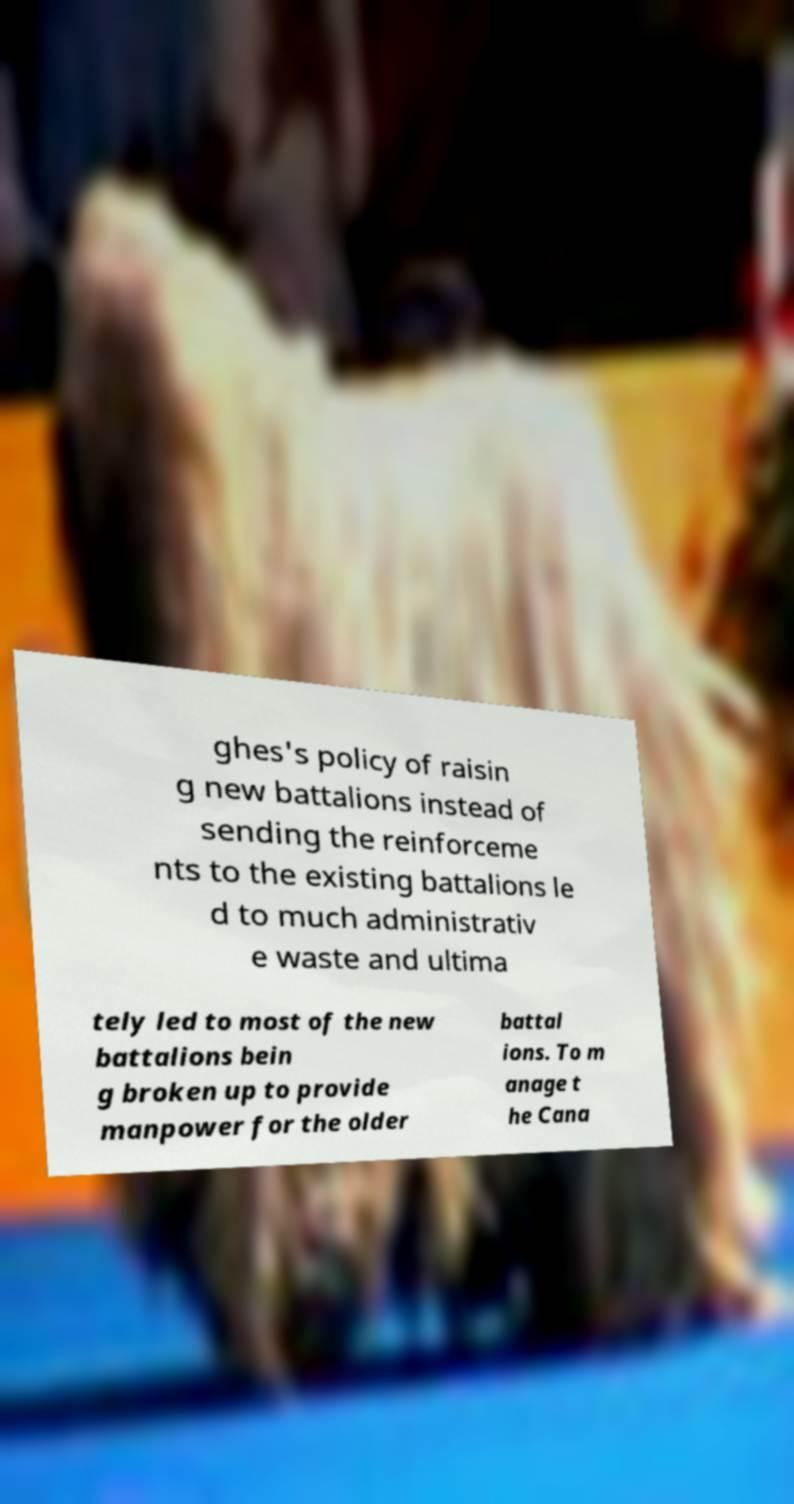Could you assist in decoding the text presented in this image and type it out clearly? ghes's policy of raisin g new battalions instead of sending the reinforceme nts to the existing battalions le d to much administrativ e waste and ultima tely led to most of the new battalions bein g broken up to provide manpower for the older battal ions. To m anage t he Cana 